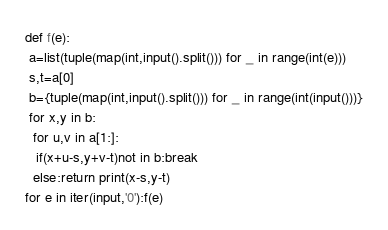Convert code to text. <code><loc_0><loc_0><loc_500><loc_500><_Python_>def f(e):
 a=list(tuple(map(int,input().split())) for _ in range(int(e)))
 s,t=a[0]
 b={tuple(map(int,input().split())) for _ in range(int(input()))}
 for x,y in b:
  for u,v in a[1:]:
   if(x+u-s,y+v-t)not in b:break
  else:return print(x-s,y-t)
for e in iter(input,'0'):f(e)
</code> 